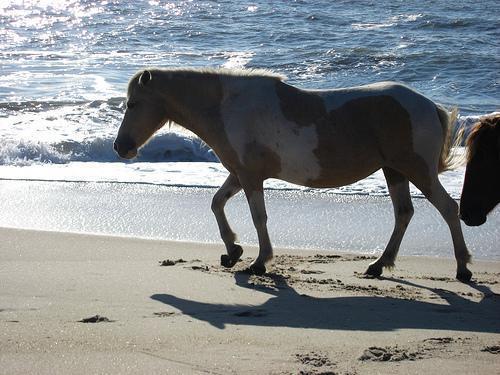How many horses are on the beach?
Give a very brief answer. 2. 